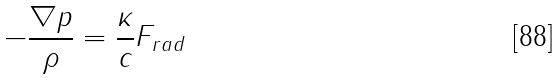<formula> <loc_0><loc_0><loc_500><loc_500>- \frac { \nabla p } { \rho } = \frac { \kappa } { c } F _ { r a d }</formula> 